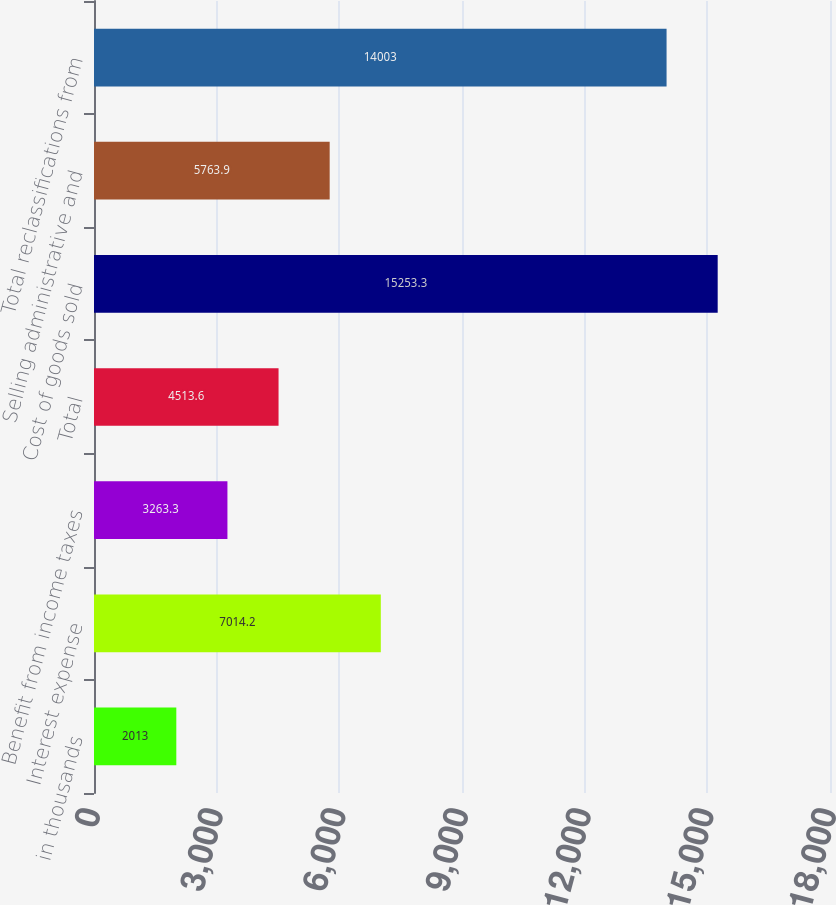<chart> <loc_0><loc_0><loc_500><loc_500><bar_chart><fcel>in thousands<fcel>Interest expense<fcel>Benefit from income taxes<fcel>Total<fcel>Cost of goods sold<fcel>Selling administrative and<fcel>Total reclassifications from<nl><fcel>2013<fcel>7014.2<fcel>3263.3<fcel>4513.6<fcel>15253.3<fcel>5763.9<fcel>14003<nl></chart> 